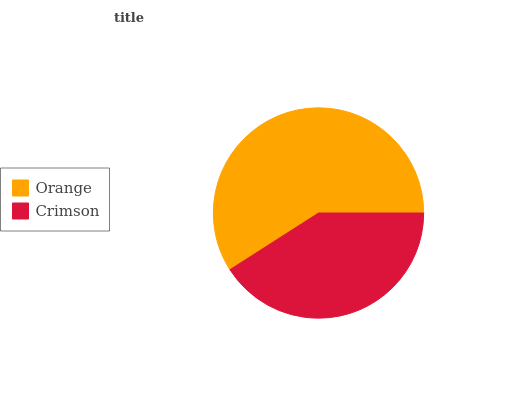Is Crimson the minimum?
Answer yes or no. Yes. Is Orange the maximum?
Answer yes or no. Yes. Is Crimson the maximum?
Answer yes or no. No. Is Orange greater than Crimson?
Answer yes or no. Yes. Is Crimson less than Orange?
Answer yes or no. Yes. Is Crimson greater than Orange?
Answer yes or no. No. Is Orange less than Crimson?
Answer yes or no. No. Is Orange the high median?
Answer yes or no. Yes. Is Crimson the low median?
Answer yes or no. Yes. Is Crimson the high median?
Answer yes or no. No. Is Orange the low median?
Answer yes or no. No. 